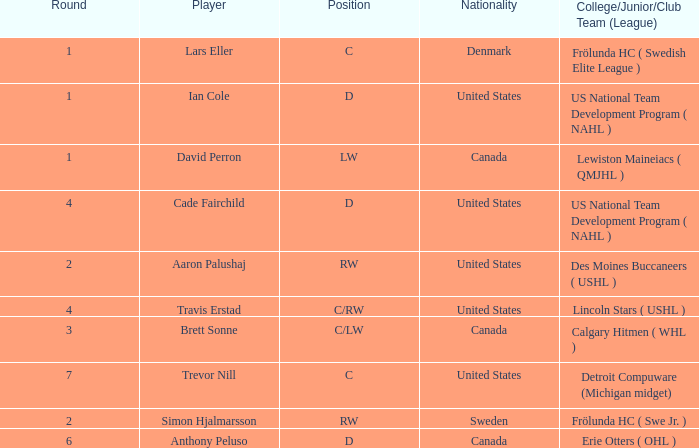Which college/junior/club team (league) did Brett Sonne play in? Calgary Hitmen ( WHL ). Parse the table in full. {'header': ['Round', 'Player', 'Position', 'Nationality', 'College/Junior/Club Team (League)'], 'rows': [['1', 'Lars Eller', 'C', 'Denmark', 'Frölunda HC ( Swedish Elite League )'], ['1', 'Ian Cole', 'D', 'United States', 'US National Team Development Program ( NAHL )'], ['1', 'David Perron', 'LW', 'Canada', 'Lewiston Maineiacs ( QMJHL )'], ['4', 'Cade Fairchild', 'D', 'United States', 'US National Team Development Program ( NAHL )'], ['2', 'Aaron Palushaj', 'RW', 'United States', 'Des Moines Buccaneers ( USHL )'], ['4', 'Travis Erstad', 'C/RW', 'United States', 'Lincoln Stars ( USHL )'], ['3', 'Brett Sonne', 'C/LW', 'Canada', 'Calgary Hitmen ( WHL )'], ['7', 'Trevor Nill', 'C', 'United States', 'Detroit Compuware (Michigan midget)'], ['2', 'Simon Hjalmarsson', 'RW', 'Sweden', 'Frölunda HC ( Swe Jr. )'], ['6', 'Anthony Peluso', 'D', 'Canada', 'Erie Otters ( OHL )']]} 